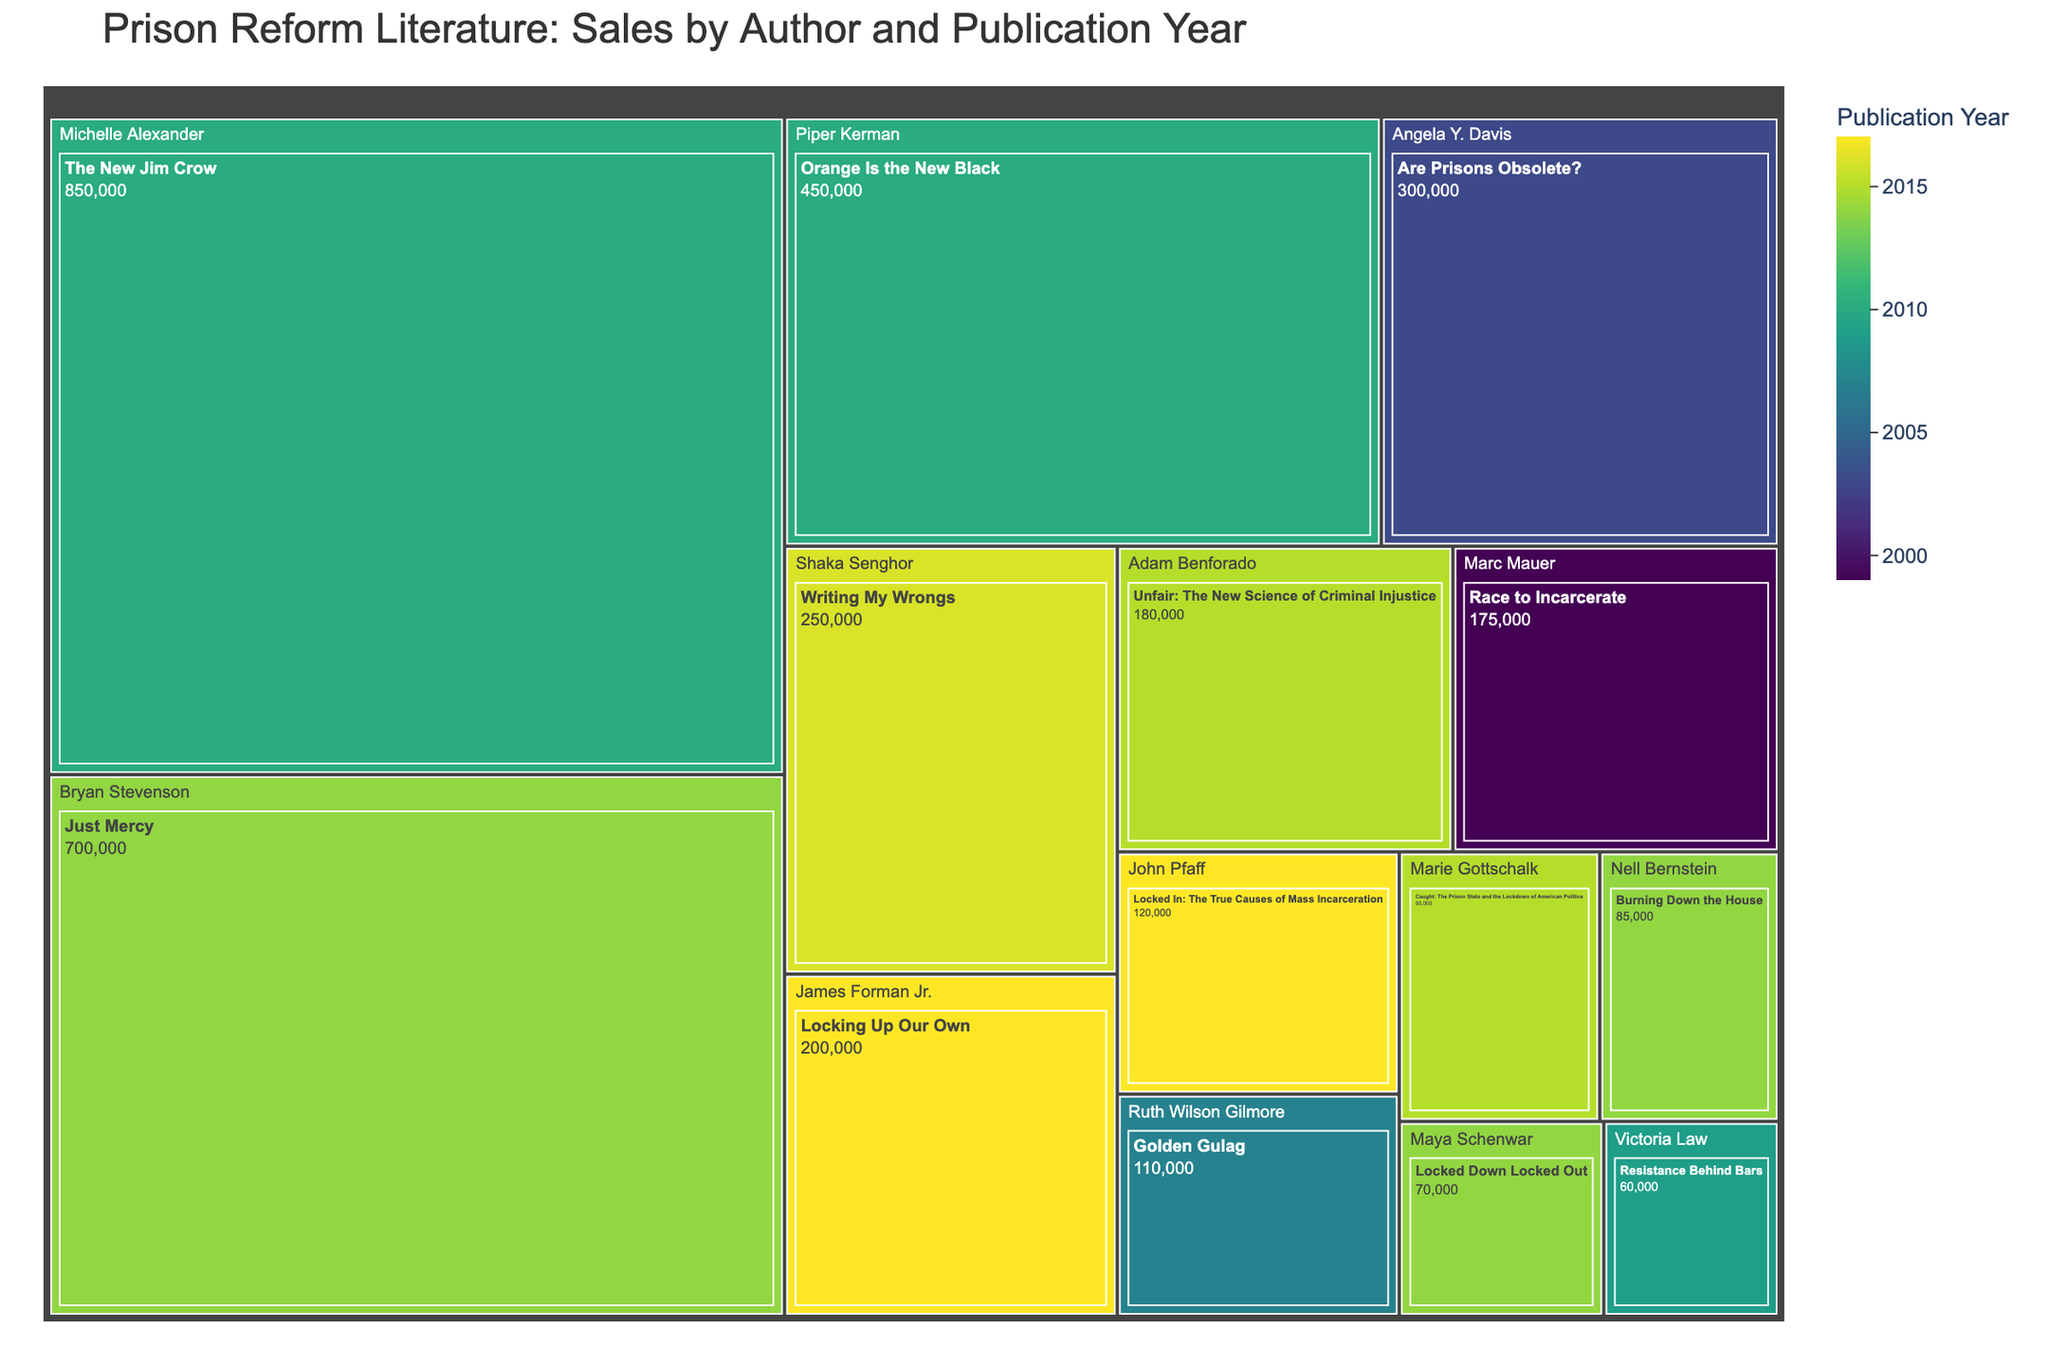What's the best-selling book on prison reform literature? The figure uses a treemap where the size of each tile represents book sales. The largest tile corresponds to the highest number of sales. By examining the tiles, we see that "The New Jim Crow" by Michelle Alexander has the largest area.
Answer: The New Jim Crow How many authors have books published in 2014? The treemap also indicates publication years. By counting the authors with books from the year 2014, one would highlight each corresponding tile.
Answer: 3 What's the total sales for books published in 2010? To determine this, sum the sales of books published in 2010: "The New Jim Crow" (850,000) and "Orange Is the New Black" (450,000).
Answer: 1,300,000 Which author has the most publications in the dataset? By reviewing the number of tiles for each author in the treemap path, we identify the author with the most book titles. Each author generally has one book listed, indicating no one author dominates in terms of quantity in this particular dataset.
Answer: No one author has multiple publications Between the books published by Bryan Stevenson and Piper Kerman, which one has higher sales and by how much? By comparing the sales of Bryan Stevenson's "Just Mercy" (700,000) with Piper Kerman's "Orange Is the New Black" (450,000), the difference is calculated: 700,000 - 450,000.
Answer: Bryan Stevenson by 250,000 What's the average sales of books published in 2017? To calculate this, sum the sales of the books published in 2017: "Locked In" (120,000) and "Locking Up Our Own" (200,000), then divide by the number of books (2). (120,000 + 200,000) / 2.
Answer: 160,000 Which book published in 2015 has higher sales? "Unfair: The New Science of Criminal Injustice" by Adam Benforado or "Caught: The Prison State and the Lockdown of American Politics" by Marie Gottschalk? Compare the sales of the two books: "Unfair" (180,000) and "Caught" (95,000).
Answer: Unfair: The New Science of Criminal Injustice How do the sales of "Writing My Wrongs" compare to "Locked In"? Compare the sales figures of "Writing My Wrongs" (250,000) and "Locked In" (120,000).
Answer: Writing My Wrongs is higher What trend can you observe from the publication year and sales color gradient? The treemap uses a color gradient to indicate publication years. By observing the gradient, one can see whether older or newer publications generally have higher sales.
Answer: No single trend indicated; it varies Which book published before 2010 has the highest sales? Identify the books published before 2010 and compare their sales: "Are Prisons Obsolete?" by Angela Y. Davis (300,000), "Golden Gulag" by Ruth Wilson Gilmore (110,000), and "Resistance Behind Bars" by Victoria Law (60,000). The highest among them is "Are Prisons Obsolete?"
Answer: Are Prisons Obsolete? 